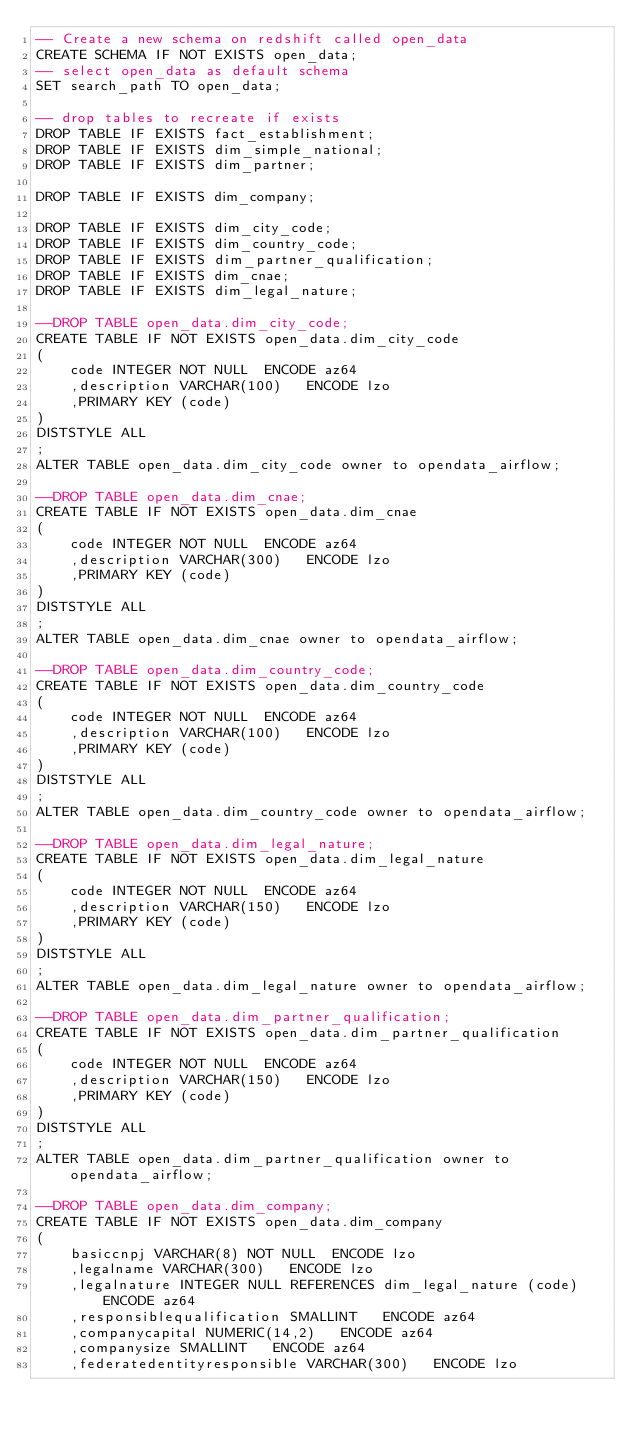<code> <loc_0><loc_0><loc_500><loc_500><_SQL_>-- Create a new schema on redshift called open_data
CREATE SCHEMA IF NOT EXISTS open_data;
-- select open_data as default schema 
SET search_path TO open_data;

-- drop tables to recreate if exists
DROP TABLE IF EXISTS fact_establishment;
DROP TABLE IF EXISTS dim_simple_national;
DROP TABLE IF EXISTS dim_partner;

DROP TABLE IF EXISTS dim_company;

DROP TABLE IF EXISTS dim_city_code;
DROP TABLE IF EXISTS dim_country_code;
DROP TABLE IF EXISTS dim_partner_qualification;
DROP TABLE IF EXISTS dim_cnae;
DROP TABLE IF EXISTS dim_legal_nature;

--DROP TABLE open_data.dim_city_code;
CREATE TABLE IF NOT EXISTS open_data.dim_city_code
(
	code INTEGER NOT NULL  ENCODE az64
	,description VARCHAR(100)   ENCODE lzo
	,PRIMARY KEY (code)
)
DISTSTYLE ALL
;
ALTER TABLE open_data.dim_city_code owner to opendata_airflow;

--DROP TABLE open_data.dim_cnae;
CREATE TABLE IF NOT EXISTS open_data.dim_cnae
(
	code INTEGER NOT NULL  ENCODE az64
	,description VARCHAR(300)   ENCODE lzo
	,PRIMARY KEY (code)
)
DISTSTYLE ALL
;
ALTER TABLE open_data.dim_cnae owner to opendata_airflow;

--DROP TABLE open_data.dim_country_code;
CREATE TABLE IF NOT EXISTS open_data.dim_country_code
(
	code INTEGER NOT NULL  ENCODE az64
	,description VARCHAR(100)   ENCODE lzo
	,PRIMARY KEY (code)
)
DISTSTYLE ALL
;
ALTER TABLE open_data.dim_country_code owner to opendata_airflow;

--DROP TABLE open_data.dim_legal_nature;
CREATE TABLE IF NOT EXISTS open_data.dim_legal_nature
(
	code INTEGER NOT NULL  ENCODE az64
	,description VARCHAR(150)   ENCODE lzo
	,PRIMARY KEY (code)
)
DISTSTYLE ALL
;
ALTER TABLE open_data.dim_legal_nature owner to opendata_airflow;

--DROP TABLE open_data.dim_partner_qualification;
CREATE TABLE IF NOT EXISTS open_data.dim_partner_qualification
(
	code INTEGER NOT NULL  ENCODE az64
	,description VARCHAR(150)   ENCODE lzo
	,PRIMARY KEY (code)
)
DISTSTYLE ALL
;
ALTER TABLE open_data.dim_partner_qualification owner to opendata_airflow;

--DROP TABLE open_data.dim_company;
CREATE TABLE IF NOT EXISTS open_data.dim_company
(
	basiccnpj VARCHAR(8) NOT NULL  ENCODE lzo
	,legalname VARCHAR(300)   ENCODE lzo
	,legalnature INTEGER NULL REFERENCES dim_legal_nature (code) ENCODE az64
	,responsiblequalification SMALLINT   ENCODE az64
	,companycapital NUMERIC(14,2)   ENCODE az64
	,companysize SMALLINT   ENCODE az64
	,federatedentityresponsible VARCHAR(300)   ENCODE lzo</code> 